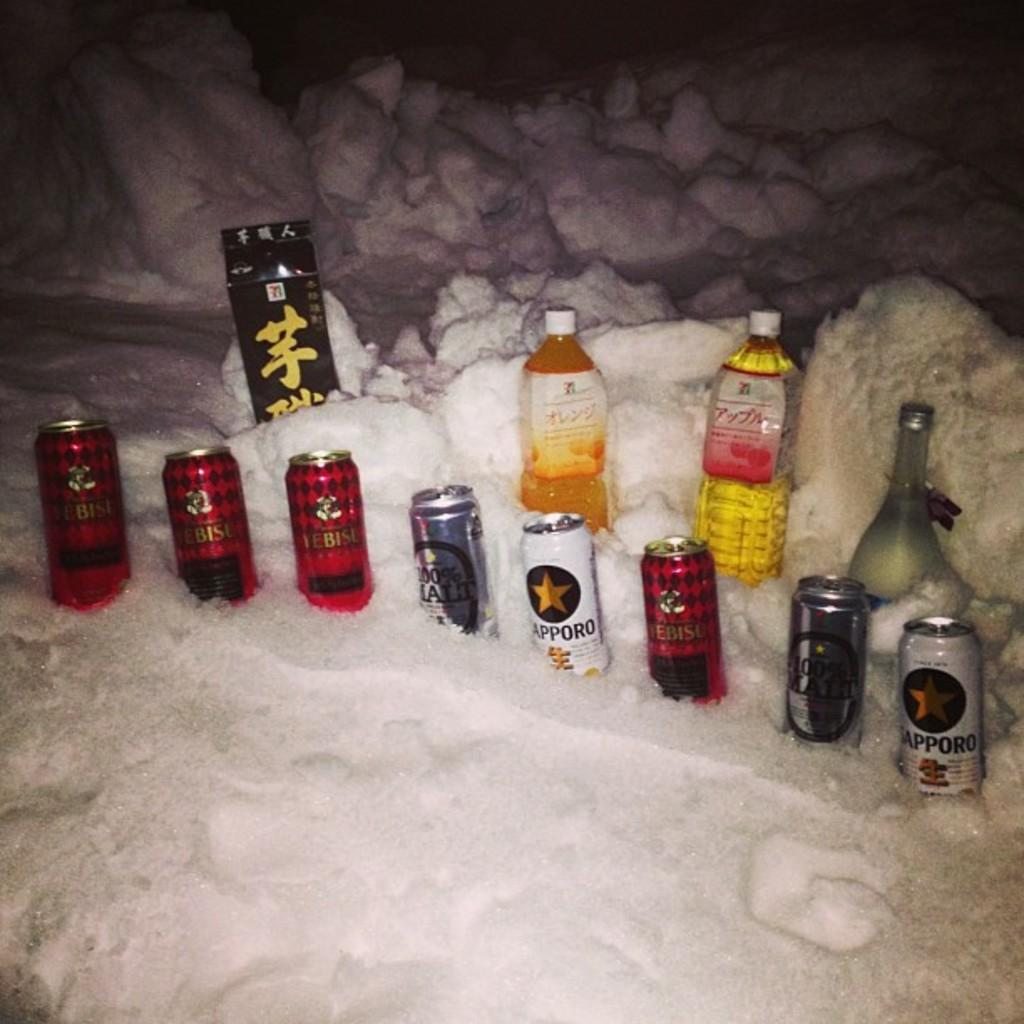<image>
Summarize the visual content of the image. A couple of Sapporo beers sit in ice along with other brands. 